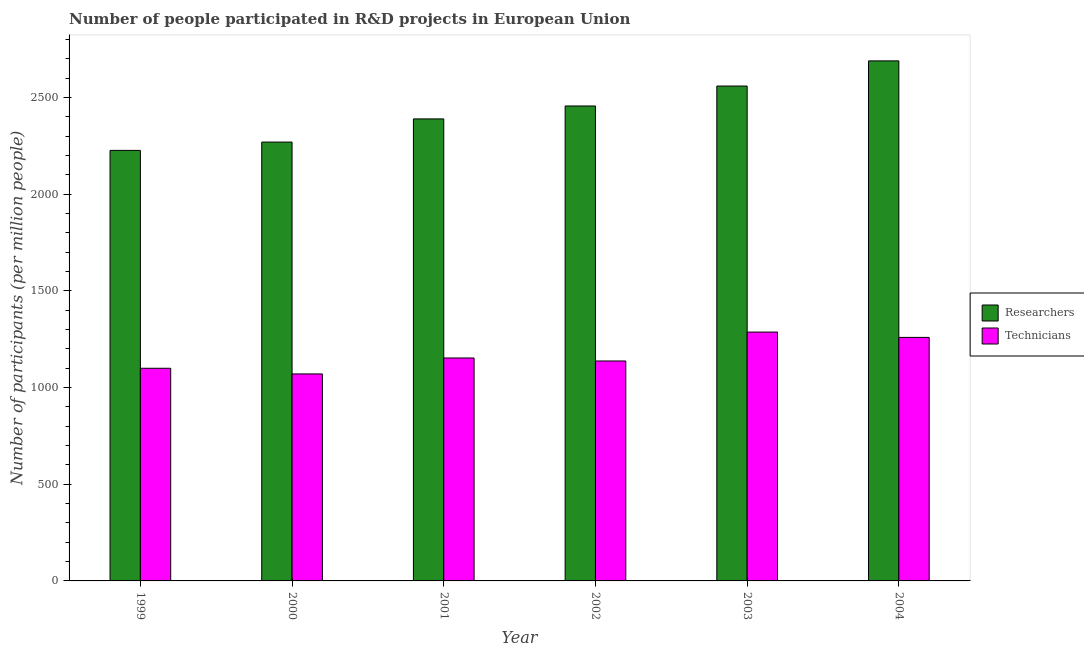How many different coloured bars are there?
Keep it short and to the point. 2. How many groups of bars are there?
Provide a succinct answer. 6. What is the label of the 2nd group of bars from the left?
Provide a short and direct response. 2000. In how many cases, is the number of bars for a given year not equal to the number of legend labels?
Give a very brief answer. 0. What is the number of researchers in 2002?
Offer a very short reply. 2455.76. Across all years, what is the maximum number of researchers?
Provide a short and direct response. 2688.97. Across all years, what is the minimum number of technicians?
Offer a terse response. 1070.3. What is the total number of researchers in the graph?
Offer a terse response. 1.46e+04. What is the difference between the number of technicians in 2001 and that in 2002?
Offer a very short reply. 15.51. What is the difference between the number of researchers in 2000 and the number of technicians in 2002?
Your answer should be very brief. -186.6. What is the average number of technicians per year?
Provide a succinct answer. 1167.62. In how many years, is the number of technicians greater than 300?
Your response must be concise. 6. What is the ratio of the number of researchers in 2001 to that in 2004?
Give a very brief answer. 0.89. Is the number of researchers in 2001 less than that in 2004?
Offer a terse response. Yes. Is the difference between the number of technicians in 2000 and 2002 greater than the difference between the number of researchers in 2000 and 2002?
Ensure brevity in your answer.  No. What is the difference between the highest and the second highest number of researchers?
Ensure brevity in your answer.  130.11. What is the difference between the highest and the lowest number of technicians?
Make the answer very short. 216.44. In how many years, is the number of technicians greater than the average number of technicians taken over all years?
Keep it short and to the point. 2. What does the 2nd bar from the left in 2001 represents?
Your answer should be compact. Technicians. What does the 2nd bar from the right in 2001 represents?
Provide a short and direct response. Researchers. Are all the bars in the graph horizontal?
Ensure brevity in your answer.  No. How many years are there in the graph?
Keep it short and to the point. 6. Are the values on the major ticks of Y-axis written in scientific E-notation?
Keep it short and to the point. No. Where does the legend appear in the graph?
Your answer should be very brief. Center right. How are the legend labels stacked?
Provide a succinct answer. Vertical. What is the title of the graph?
Keep it short and to the point. Number of people participated in R&D projects in European Union. What is the label or title of the X-axis?
Offer a very short reply. Year. What is the label or title of the Y-axis?
Provide a succinct answer. Number of participants (per million people). What is the Number of participants (per million people) of Researchers in 1999?
Keep it short and to the point. 2226.11. What is the Number of participants (per million people) of Technicians in 1999?
Provide a succinct answer. 1099.52. What is the Number of participants (per million people) in Researchers in 2000?
Make the answer very short. 2269.16. What is the Number of participants (per million people) of Technicians in 2000?
Make the answer very short. 1070.3. What is the Number of participants (per million people) in Researchers in 2001?
Offer a very short reply. 2388.92. What is the Number of participants (per million people) in Technicians in 2001?
Offer a very short reply. 1152.73. What is the Number of participants (per million people) in Researchers in 2002?
Provide a succinct answer. 2455.76. What is the Number of participants (per million people) in Technicians in 2002?
Give a very brief answer. 1137.23. What is the Number of participants (per million people) of Researchers in 2003?
Your answer should be very brief. 2558.87. What is the Number of participants (per million people) in Technicians in 2003?
Make the answer very short. 1286.74. What is the Number of participants (per million people) of Researchers in 2004?
Provide a short and direct response. 2688.97. What is the Number of participants (per million people) in Technicians in 2004?
Make the answer very short. 1259.21. Across all years, what is the maximum Number of participants (per million people) of Researchers?
Ensure brevity in your answer.  2688.97. Across all years, what is the maximum Number of participants (per million people) in Technicians?
Provide a short and direct response. 1286.74. Across all years, what is the minimum Number of participants (per million people) in Researchers?
Ensure brevity in your answer.  2226.11. Across all years, what is the minimum Number of participants (per million people) in Technicians?
Provide a succinct answer. 1070.3. What is the total Number of participants (per million people) of Researchers in the graph?
Make the answer very short. 1.46e+04. What is the total Number of participants (per million people) of Technicians in the graph?
Ensure brevity in your answer.  7005.74. What is the difference between the Number of participants (per million people) in Researchers in 1999 and that in 2000?
Give a very brief answer. -43.05. What is the difference between the Number of participants (per million people) in Technicians in 1999 and that in 2000?
Offer a terse response. 29.22. What is the difference between the Number of participants (per million people) of Researchers in 1999 and that in 2001?
Offer a terse response. -162.81. What is the difference between the Number of participants (per million people) of Technicians in 1999 and that in 2001?
Make the answer very short. -53.21. What is the difference between the Number of participants (per million people) in Researchers in 1999 and that in 2002?
Ensure brevity in your answer.  -229.66. What is the difference between the Number of participants (per million people) of Technicians in 1999 and that in 2002?
Provide a succinct answer. -37.71. What is the difference between the Number of participants (per million people) of Researchers in 1999 and that in 2003?
Your answer should be very brief. -332.76. What is the difference between the Number of participants (per million people) in Technicians in 1999 and that in 2003?
Your answer should be compact. -187.22. What is the difference between the Number of participants (per million people) of Researchers in 1999 and that in 2004?
Ensure brevity in your answer.  -462.87. What is the difference between the Number of participants (per million people) of Technicians in 1999 and that in 2004?
Provide a short and direct response. -159.68. What is the difference between the Number of participants (per million people) of Researchers in 2000 and that in 2001?
Ensure brevity in your answer.  -119.76. What is the difference between the Number of participants (per million people) in Technicians in 2000 and that in 2001?
Ensure brevity in your answer.  -82.43. What is the difference between the Number of participants (per million people) in Researchers in 2000 and that in 2002?
Give a very brief answer. -186.6. What is the difference between the Number of participants (per million people) in Technicians in 2000 and that in 2002?
Offer a terse response. -66.92. What is the difference between the Number of participants (per million people) of Researchers in 2000 and that in 2003?
Your answer should be compact. -289.71. What is the difference between the Number of participants (per million people) of Technicians in 2000 and that in 2003?
Keep it short and to the point. -216.44. What is the difference between the Number of participants (per million people) in Researchers in 2000 and that in 2004?
Provide a succinct answer. -419.82. What is the difference between the Number of participants (per million people) of Technicians in 2000 and that in 2004?
Provide a succinct answer. -188.9. What is the difference between the Number of participants (per million people) of Researchers in 2001 and that in 2002?
Provide a succinct answer. -66.85. What is the difference between the Number of participants (per million people) in Technicians in 2001 and that in 2002?
Your answer should be compact. 15.51. What is the difference between the Number of participants (per million people) in Researchers in 2001 and that in 2003?
Your answer should be compact. -169.95. What is the difference between the Number of participants (per million people) of Technicians in 2001 and that in 2003?
Keep it short and to the point. -134.01. What is the difference between the Number of participants (per million people) in Researchers in 2001 and that in 2004?
Offer a terse response. -300.06. What is the difference between the Number of participants (per million people) of Technicians in 2001 and that in 2004?
Offer a terse response. -106.47. What is the difference between the Number of participants (per million people) in Researchers in 2002 and that in 2003?
Give a very brief answer. -103.1. What is the difference between the Number of participants (per million people) of Technicians in 2002 and that in 2003?
Offer a very short reply. -149.52. What is the difference between the Number of participants (per million people) of Researchers in 2002 and that in 2004?
Make the answer very short. -233.21. What is the difference between the Number of participants (per million people) of Technicians in 2002 and that in 2004?
Your response must be concise. -121.98. What is the difference between the Number of participants (per million people) in Researchers in 2003 and that in 2004?
Your answer should be compact. -130.11. What is the difference between the Number of participants (per million people) of Technicians in 2003 and that in 2004?
Provide a succinct answer. 27.54. What is the difference between the Number of participants (per million people) in Researchers in 1999 and the Number of participants (per million people) in Technicians in 2000?
Offer a terse response. 1155.8. What is the difference between the Number of participants (per million people) of Researchers in 1999 and the Number of participants (per million people) of Technicians in 2001?
Provide a succinct answer. 1073.37. What is the difference between the Number of participants (per million people) of Researchers in 1999 and the Number of participants (per million people) of Technicians in 2002?
Make the answer very short. 1088.88. What is the difference between the Number of participants (per million people) in Researchers in 1999 and the Number of participants (per million people) in Technicians in 2003?
Give a very brief answer. 939.36. What is the difference between the Number of participants (per million people) of Researchers in 1999 and the Number of participants (per million people) of Technicians in 2004?
Give a very brief answer. 966.9. What is the difference between the Number of participants (per million people) of Researchers in 2000 and the Number of participants (per million people) of Technicians in 2001?
Offer a very short reply. 1116.43. What is the difference between the Number of participants (per million people) in Researchers in 2000 and the Number of participants (per million people) in Technicians in 2002?
Your response must be concise. 1131.93. What is the difference between the Number of participants (per million people) in Researchers in 2000 and the Number of participants (per million people) in Technicians in 2003?
Give a very brief answer. 982.41. What is the difference between the Number of participants (per million people) of Researchers in 2000 and the Number of participants (per million people) of Technicians in 2004?
Make the answer very short. 1009.95. What is the difference between the Number of participants (per million people) in Researchers in 2001 and the Number of participants (per million people) in Technicians in 2002?
Your answer should be very brief. 1251.69. What is the difference between the Number of participants (per million people) of Researchers in 2001 and the Number of participants (per million people) of Technicians in 2003?
Your answer should be compact. 1102.17. What is the difference between the Number of participants (per million people) in Researchers in 2001 and the Number of participants (per million people) in Technicians in 2004?
Provide a succinct answer. 1129.71. What is the difference between the Number of participants (per million people) of Researchers in 2002 and the Number of participants (per million people) of Technicians in 2003?
Your answer should be very brief. 1169.02. What is the difference between the Number of participants (per million people) in Researchers in 2002 and the Number of participants (per million people) in Technicians in 2004?
Your answer should be very brief. 1196.56. What is the difference between the Number of participants (per million people) of Researchers in 2003 and the Number of participants (per million people) of Technicians in 2004?
Your response must be concise. 1299.66. What is the average Number of participants (per million people) in Researchers per year?
Provide a short and direct response. 2431.3. What is the average Number of participants (per million people) of Technicians per year?
Keep it short and to the point. 1167.62. In the year 1999, what is the difference between the Number of participants (per million people) of Researchers and Number of participants (per million people) of Technicians?
Offer a very short reply. 1126.59. In the year 2000, what is the difference between the Number of participants (per million people) of Researchers and Number of participants (per million people) of Technicians?
Your response must be concise. 1198.85. In the year 2001, what is the difference between the Number of participants (per million people) in Researchers and Number of participants (per million people) in Technicians?
Offer a very short reply. 1236.18. In the year 2002, what is the difference between the Number of participants (per million people) of Researchers and Number of participants (per million people) of Technicians?
Offer a very short reply. 1318.54. In the year 2003, what is the difference between the Number of participants (per million people) of Researchers and Number of participants (per million people) of Technicians?
Provide a succinct answer. 1272.12. In the year 2004, what is the difference between the Number of participants (per million people) of Researchers and Number of participants (per million people) of Technicians?
Provide a succinct answer. 1429.77. What is the ratio of the Number of participants (per million people) of Researchers in 1999 to that in 2000?
Make the answer very short. 0.98. What is the ratio of the Number of participants (per million people) of Technicians in 1999 to that in 2000?
Provide a short and direct response. 1.03. What is the ratio of the Number of participants (per million people) in Researchers in 1999 to that in 2001?
Give a very brief answer. 0.93. What is the ratio of the Number of participants (per million people) of Technicians in 1999 to that in 2001?
Give a very brief answer. 0.95. What is the ratio of the Number of participants (per million people) in Researchers in 1999 to that in 2002?
Make the answer very short. 0.91. What is the ratio of the Number of participants (per million people) in Technicians in 1999 to that in 2002?
Provide a short and direct response. 0.97. What is the ratio of the Number of participants (per million people) in Researchers in 1999 to that in 2003?
Give a very brief answer. 0.87. What is the ratio of the Number of participants (per million people) of Technicians in 1999 to that in 2003?
Give a very brief answer. 0.85. What is the ratio of the Number of participants (per million people) of Researchers in 1999 to that in 2004?
Provide a short and direct response. 0.83. What is the ratio of the Number of participants (per million people) of Technicians in 1999 to that in 2004?
Your answer should be very brief. 0.87. What is the ratio of the Number of participants (per million people) in Researchers in 2000 to that in 2001?
Provide a succinct answer. 0.95. What is the ratio of the Number of participants (per million people) of Technicians in 2000 to that in 2001?
Ensure brevity in your answer.  0.93. What is the ratio of the Number of participants (per million people) in Researchers in 2000 to that in 2002?
Make the answer very short. 0.92. What is the ratio of the Number of participants (per million people) in Researchers in 2000 to that in 2003?
Make the answer very short. 0.89. What is the ratio of the Number of participants (per million people) of Technicians in 2000 to that in 2003?
Offer a very short reply. 0.83. What is the ratio of the Number of participants (per million people) of Researchers in 2000 to that in 2004?
Your answer should be compact. 0.84. What is the ratio of the Number of participants (per million people) in Technicians in 2000 to that in 2004?
Provide a succinct answer. 0.85. What is the ratio of the Number of participants (per million people) of Researchers in 2001 to that in 2002?
Your answer should be compact. 0.97. What is the ratio of the Number of participants (per million people) of Technicians in 2001 to that in 2002?
Offer a very short reply. 1.01. What is the ratio of the Number of participants (per million people) of Researchers in 2001 to that in 2003?
Provide a short and direct response. 0.93. What is the ratio of the Number of participants (per million people) of Technicians in 2001 to that in 2003?
Offer a terse response. 0.9. What is the ratio of the Number of participants (per million people) in Researchers in 2001 to that in 2004?
Provide a succinct answer. 0.89. What is the ratio of the Number of participants (per million people) of Technicians in 2001 to that in 2004?
Make the answer very short. 0.92. What is the ratio of the Number of participants (per million people) in Researchers in 2002 to that in 2003?
Provide a succinct answer. 0.96. What is the ratio of the Number of participants (per million people) in Technicians in 2002 to that in 2003?
Offer a terse response. 0.88. What is the ratio of the Number of participants (per million people) of Researchers in 2002 to that in 2004?
Give a very brief answer. 0.91. What is the ratio of the Number of participants (per million people) in Technicians in 2002 to that in 2004?
Provide a short and direct response. 0.9. What is the ratio of the Number of participants (per million people) of Researchers in 2003 to that in 2004?
Give a very brief answer. 0.95. What is the ratio of the Number of participants (per million people) in Technicians in 2003 to that in 2004?
Your response must be concise. 1.02. What is the difference between the highest and the second highest Number of participants (per million people) in Researchers?
Provide a succinct answer. 130.11. What is the difference between the highest and the second highest Number of participants (per million people) of Technicians?
Provide a succinct answer. 27.54. What is the difference between the highest and the lowest Number of participants (per million people) of Researchers?
Offer a terse response. 462.87. What is the difference between the highest and the lowest Number of participants (per million people) of Technicians?
Offer a terse response. 216.44. 